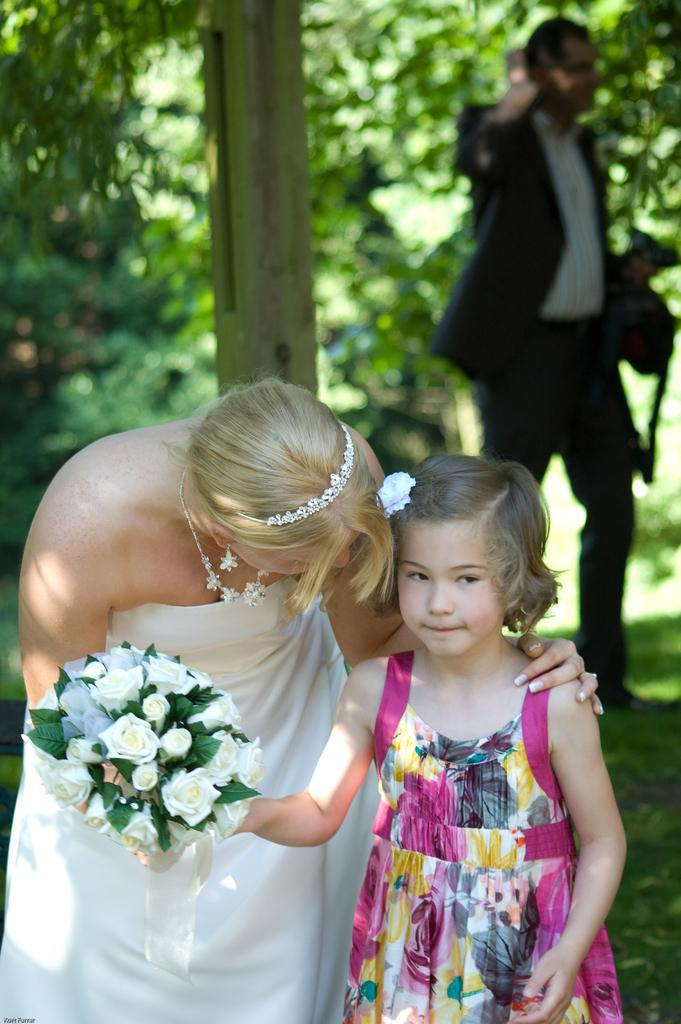Who are the people in the image? There is a woman and a girl in the image. What are the woman and the girl holding? Both the woman and the girl are holding a book. Can you describe the background of the image? There is a man in the background of the image, and there are trees as well. What invention can be seen in the hands of the woman and the girl? There is no invention present in the hands of the woman and the girl; they are holding a book. 